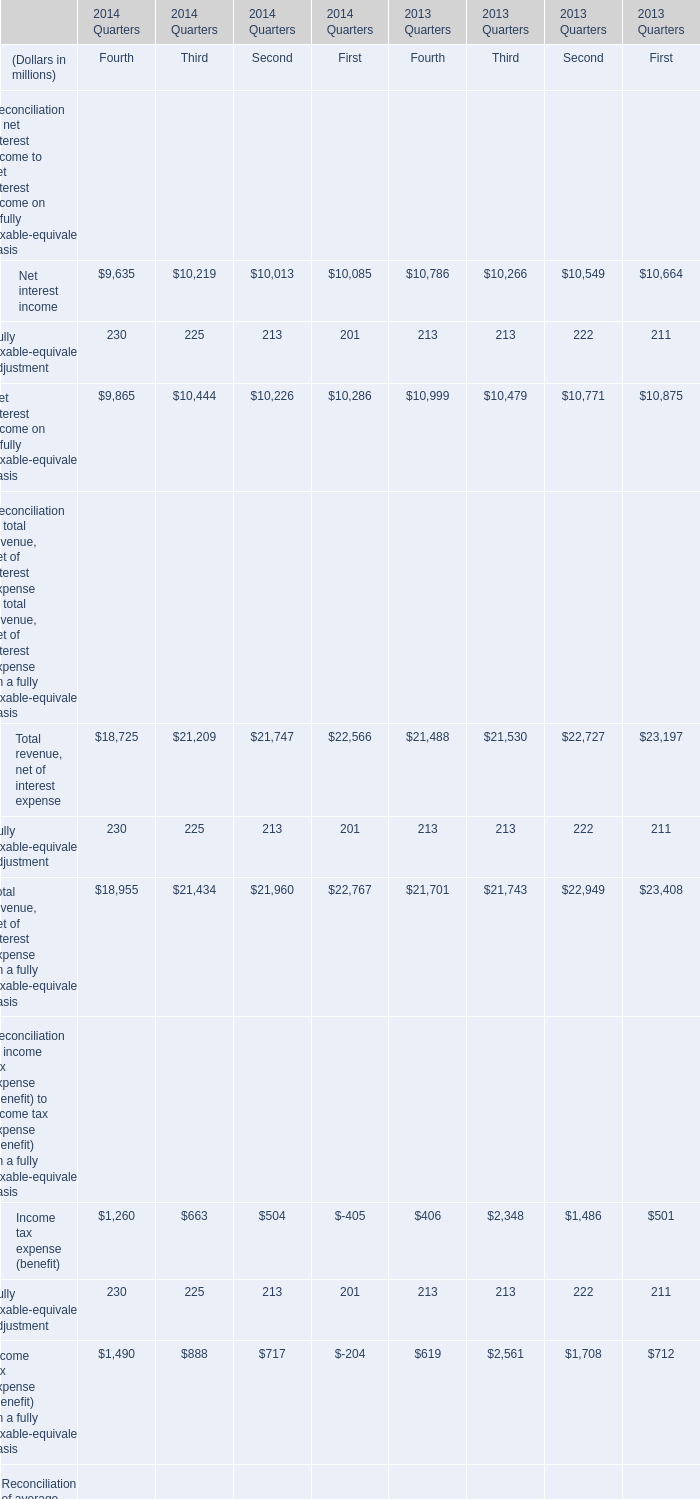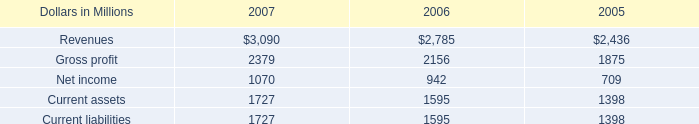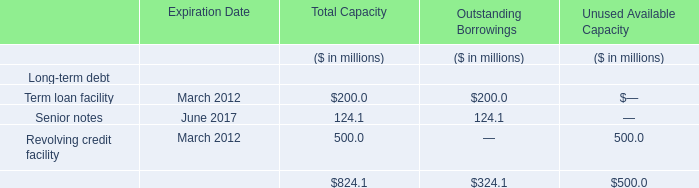What's the average of Current liabilities of 2006, and Net interest income of 2014 Quarters Second ? 
Computations: ((1595.0 + 10013.0) / 2)
Answer: 5804.0. 